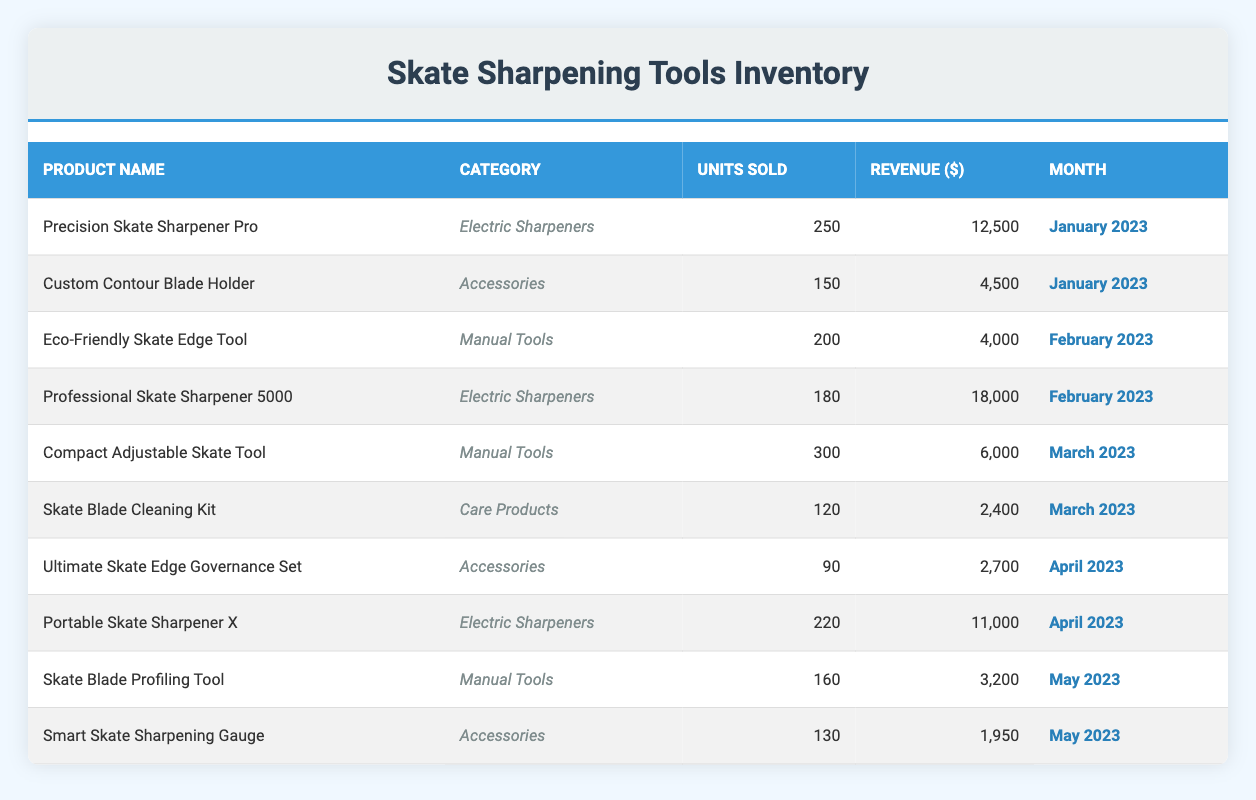What was the total revenue from electric sharpeners in February 2023? In February 2023, there are two electric sharpeners listed: Professional Skate Sharpener 5000 with a revenue of 18,000, and there are no other electric sharpeners in that month. Therefore, the total revenue from electric sharpeners is 18,000.
Answer: 18,000 How many units of accessories were sold in January 2023? In January 2023, there was one accessory sold, the Custom Contour Blade Holder, with units sold amounting to 150. There are no other accessories listed in that month.
Answer: 150 Is the Skate Blade Cleaning Kit classified as a manual tool? The Skate Blade Cleaning Kit is listed under the category "Care Products," not "Manual Tools," thus it is not classified as a manual tool.
Answer: No What are the units sold for the Portable Skate Sharpener X in April 2023? The Portable Skate Sharpener X is listed in April 2023 with units sold totaling 220.
Answer: 220 What is the average revenue generated by manual tools across the months? The manual tools are Eco-Friendly Skate Edge Tool (4,000), Compact Adjustable Skate Tool (6,000), and Skate Blade Profiling Tool (3,200). To find the average, we sum these revenues (4,000 + 6,000 + 3,200 = 13,200) and divide by the number of manual tools (3), yielding an average of 4,400.
Answer: 4,400 Which product had the highest revenue in March 2023, and what was it? In March 2023, the products sold were Compact Adjustable Skate Tool (6,000) and Skate Blade Cleaning Kit (2,400). The highest revenue is from the Compact Adjustable Skate Tool with 6,000.
Answer: Compact Adjustable Skate Tool, 6,000 How many total units were sold in May 2023? The total units sold in May 2023 include Skate Blade Profiling Tool (160) and Smart Skate Sharpening Gauge (130). Adding these gives a total of 290 units sold in May 2023 (160 + 130).
Answer: 290 Is the revenue from accessories in April 2023 greater than 3,000? In April 2023, the only accessory listed is the Ultimate Skate Edge Governance Set with a revenue of 2,700, which is less than 3,000.
Answer: No What was the month with the highest total units sold? By looking at all the months, January had 250 (Precision Skate Sharpener Pro) + 150 (Custom Contour Blade Holder) = 400, February had 180 + 200 = 380, March had 300 + 120 = 420, April had 220 + 90 = 310, and May had 160 + 130 = 290. The highest total is 420 in March 2023.
Answer: March 2023 